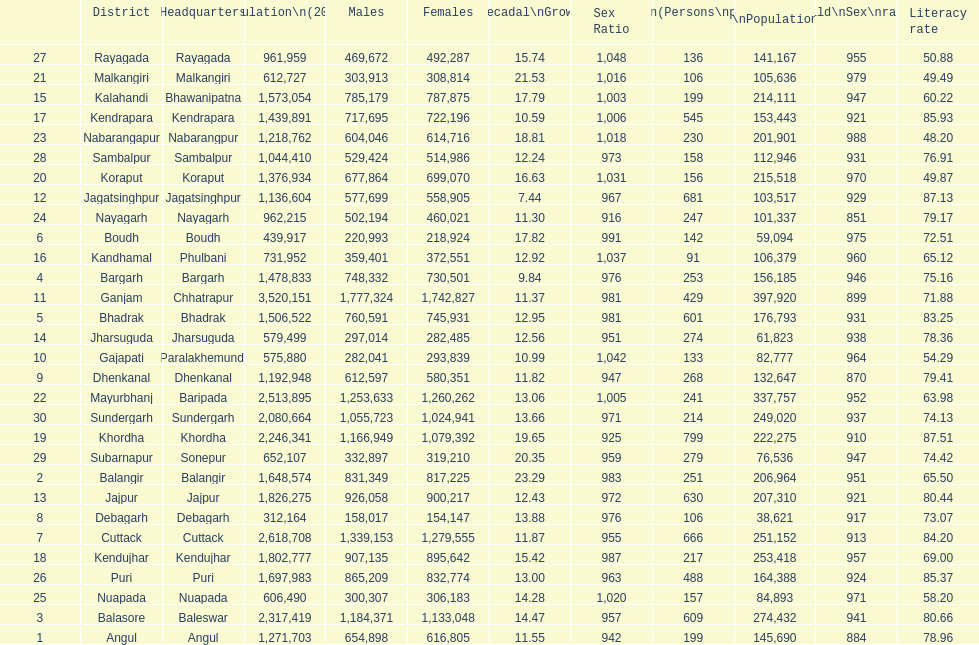Can you give me this table as a dict? {'header': ['', 'District', 'Headquarters', 'Population\\n(2011)', 'Males', 'Females', 'Percentage\\nDecadal\\nGrowth\\n2001-2011', 'Sex Ratio', 'Density\\n(Persons\\nper\\nkm2)', 'Child\\nPopulation\\n0–6 years', 'Child\\nSex\\nratio', 'Literacy rate'], 'rows': [['27', 'Rayagada', 'Rayagada', '961,959', '469,672', '492,287', '15.74', '1,048', '136', '141,167', '955', '50.88'], ['21', 'Malkangiri', 'Malkangiri', '612,727', '303,913', '308,814', '21.53', '1,016', '106', '105,636', '979', '49.49'], ['15', 'Kalahandi', 'Bhawanipatna', '1,573,054', '785,179', '787,875', '17.79', '1,003', '199', '214,111', '947', '60.22'], ['17', 'Kendrapara', 'Kendrapara', '1,439,891', '717,695', '722,196', '10.59', '1,006', '545', '153,443', '921', '85.93'], ['23', 'Nabarangapur', 'Nabarangpur', '1,218,762', '604,046', '614,716', '18.81', '1,018', '230', '201,901', '988', '48.20'], ['28', 'Sambalpur', 'Sambalpur', '1,044,410', '529,424', '514,986', '12.24', '973', '158', '112,946', '931', '76.91'], ['20', 'Koraput', 'Koraput', '1,376,934', '677,864', '699,070', '16.63', '1,031', '156', '215,518', '970', '49.87'], ['12', 'Jagatsinghpur', 'Jagatsinghpur', '1,136,604', '577,699', '558,905', '7.44', '967', '681', '103,517', '929', '87.13'], ['24', 'Nayagarh', 'Nayagarh', '962,215', '502,194', '460,021', '11.30', '916', '247', '101,337', '851', '79.17'], ['6', 'Boudh', 'Boudh', '439,917', '220,993', '218,924', '17.82', '991', '142', '59,094', '975', '72.51'], ['16', 'Kandhamal', 'Phulbani', '731,952', '359,401', '372,551', '12.92', '1,037', '91', '106,379', '960', '65.12'], ['4', 'Bargarh', 'Bargarh', '1,478,833', '748,332', '730,501', '9.84', '976', '253', '156,185', '946', '75.16'], ['11', 'Ganjam', 'Chhatrapur', '3,520,151', '1,777,324', '1,742,827', '11.37', '981', '429', '397,920', '899', '71.88'], ['5', 'Bhadrak', 'Bhadrak', '1,506,522', '760,591', '745,931', '12.95', '981', '601', '176,793', '931', '83.25'], ['14', 'Jharsuguda', 'Jharsuguda', '579,499', '297,014', '282,485', '12.56', '951', '274', '61,823', '938', '78.36'], ['10', 'Gajapati', 'Paralakhemundi', '575,880', '282,041', '293,839', '10.99', '1,042', '133', '82,777', '964', '54.29'], ['9', 'Dhenkanal', 'Dhenkanal', '1,192,948', '612,597', '580,351', '11.82', '947', '268', '132,647', '870', '79.41'], ['22', 'Mayurbhanj', 'Baripada', '2,513,895', '1,253,633', '1,260,262', '13.06', '1,005', '241', '337,757', '952', '63.98'], ['30', 'Sundergarh', 'Sundergarh', '2,080,664', '1,055,723', '1,024,941', '13.66', '971', '214', '249,020', '937', '74.13'], ['19', 'Khordha', 'Khordha', '2,246,341', '1,166,949', '1,079,392', '19.65', '925', '799', '222,275', '910', '87.51'], ['29', 'Subarnapur', 'Sonepur', '652,107', '332,897', '319,210', '20.35', '959', '279', '76,536', '947', '74.42'], ['2', 'Balangir', 'Balangir', '1,648,574', '831,349', '817,225', '23.29', '983', '251', '206,964', '951', '65.50'], ['13', 'Jajpur', 'Jajpur', '1,826,275', '926,058', '900,217', '12.43', '972', '630', '207,310', '921', '80.44'], ['8', 'Debagarh', 'Debagarh', '312,164', '158,017', '154,147', '13.88', '976', '106', '38,621', '917', '73.07'], ['7', 'Cuttack', 'Cuttack', '2,618,708', '1,339,153', '1,279,555', '11.87', '955', '666', '251,152', '913', '84.20'], ['18', 'Kendujhar', 'Kendujhar', '1,802,777', '907,135', '895,642', '15.42', '987', '217', '253,418', '957', '69.00'], ['26', 'Puri', 'Puri', '1,697,983', '865,209', '832,774', '13.00', '963', '488', '164,388', '924', '85.37'], ['25', 'Nuapada', 'Nuapada', '606,490', '300,307', '306,183', '14.28', '1,020', '157', '84,893', '971', '58.20'], ['3', 'Balasore', 'Baleswar', '2,317,419', '1,184,371', '1,133,048', '14.47', '957', '609', '274,432', '941', '80.66'], ['1', 'Angul', 'Angul', '1,271,703', '654,898', '616,805', '11.55', '942', '199', '145,690', '884', '78.96']]} What city is last in literacy? Nabarangapur. 